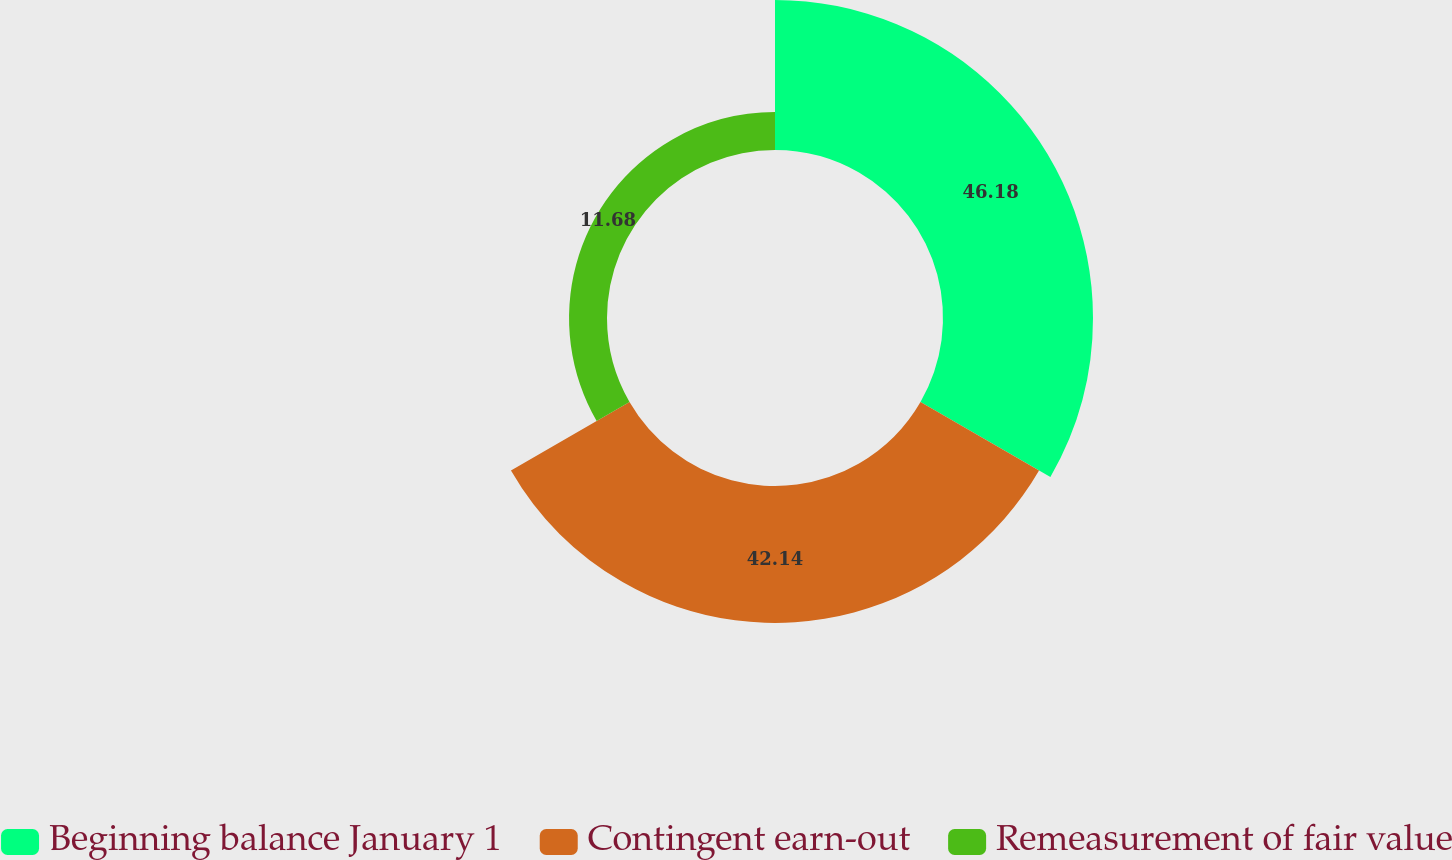<chart> <loc_0><loc_0><loc_500><loc_500><pie_chart><fcel>Beginning balance January 1<fcel>Contingent earn-out<fcel>Remeasurement of fair value<nl><fcel>46.18%<fcel>42.14%<fcel>11.68%<nl></chart> 